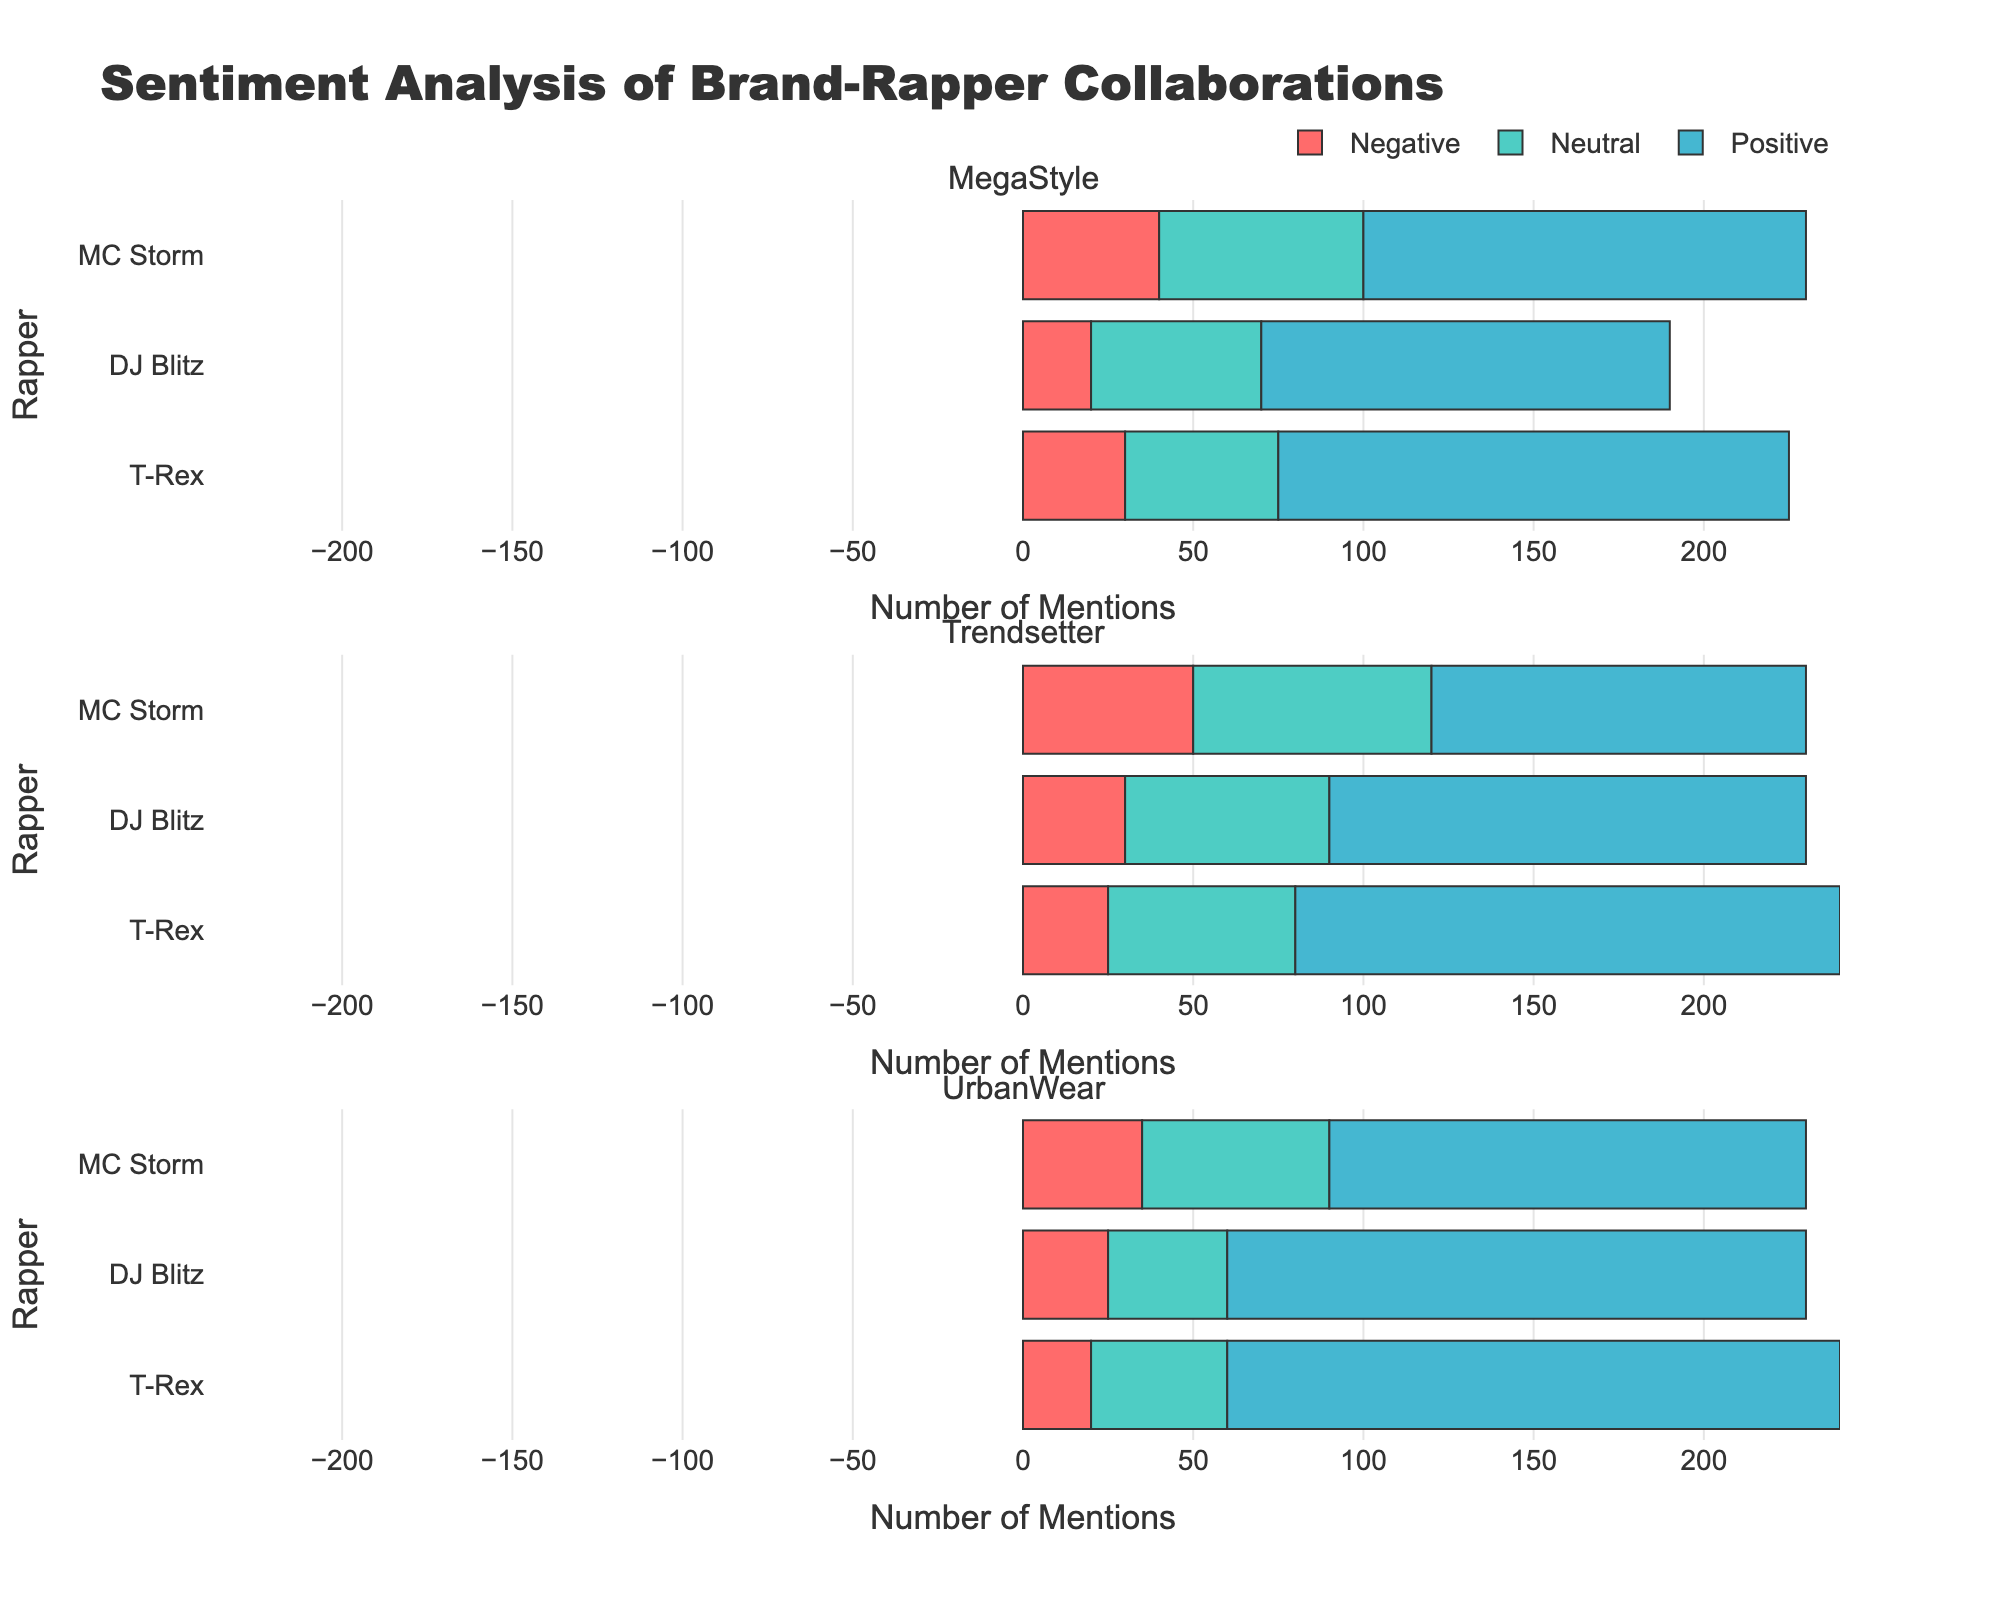Which rapper has the highest number of positive mentions for MegaStyle? To find the rapper with the highest number of positive mentions for MegaStyle, look at the "Positive" mentions for MegaStyle and compare values for each rapper. The numbers are: T-Rex (150), DJ Blitz (120), MC Storm (130). T-Rex has the highest number.
Answer: T-Rex Which brand has the most negative mentions for MC Storm? To identify the brand with the most negative mentions for MC Storm, look at the "Negative" mentions for MC Storm across all brands. The values are: MegaStyle (40), Trendsetter (50), UrbanWear (35). Trendsetter has the most negative mentions.
Answer: Trendsetter What is the total number of neutral mentions for DJ Blitz across all brands? Sum the "Neutral" mentions for DJ Blitz across each brand. The counts are: MegaStyle (50), Trendsetter (60), UrbanWear (35). Therefore, the total is 50 + 60 + 35 = 145.
Answer: 145 Who has a greater number of positive mentions for Trendsetter: T-Rex or DJ Blitz? Compare the "Positive" mentions for T-Rex and DJ Blitz under Trendsetter. T-Rex has 160 positive mentions and DJ Blitz has 140 positive mentions. T-Rex has more.
Answer: T-Rex How do the neutral mentions for T-Rex compare between MegaStyle and UrbanWear? Compare the "Neutral" mentions for T-Rex between MegaStyle and UrbanWear. MegaStyle has 45 neutral mentions and UrbanWear has 40 neutral mentions. MegaStyle has slightly more.
Answer: MegaStyle What’s the combined total of positive mentions for all rappers collaborating with UrbanWear? Sum the "Positive" mentions for all rappers collaborating with UrbanWear. The values are: T-Rex (180), DJ Blitz (170), MC Storm (140). Therefore, the total is 180 + 170 + 140 = 490.
Answer: 490 Among DJ Blitz's collaborations, which brand has the lowest number of mentions (total of positive, neutral, and negative)? Calculate the total of positive, neutral, and negative mentions for DJ Blitz’s collaborations with each brand. MegaStyle: 120+50+20=190, Trendsetter: 140+60+30=230, UrbanWear: 170+35+25=230. MegaStyle has the lowest total mentions.
Answer: MegaStyle 